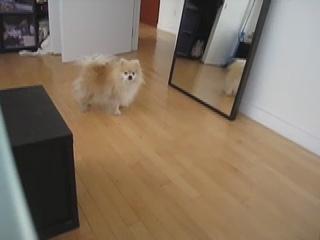What are the dogs doing?
Be succinct. Standing. What kind of animal is this?
Quick response, please. Dog. What is the dog doing?
Write a very short answer. Standing. Can you see the reflection of the dog in the mirror?
Write a very short answer. Yes. Has the building had a fresh paint job?
Answer briefly. Yes. What kind of dog is this?
Short answer required. Pomeranian. How many dogs?
Quick response, please. 1. Does this dog have a stuffed pig toy?
Quick response, please. No. Is the dog attached to a leash?
Write a very short answer. No. 